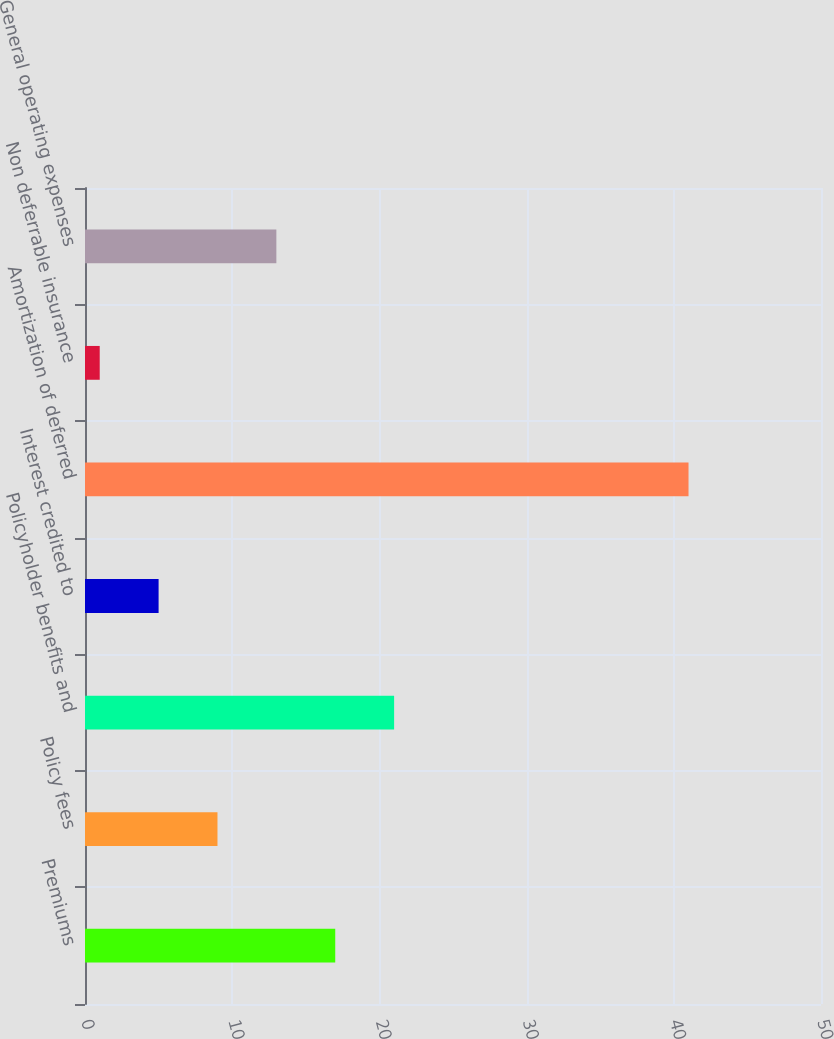<chart> <loc_0><loc_0><loc_500><loc_500><bar_chart><fcel>Premiums<fcel>Policy fees<fcel>Policyholder benefits and<fcel>Interest credited to<fcel>Amortization of deferred<fcel>Non deferrable insurance<fcel>General operating expenses<nl><fcel>17<fcel>9<fcel>21<fcel>5<fcel>41<fcel>1<fcel>13<nl></chart> 